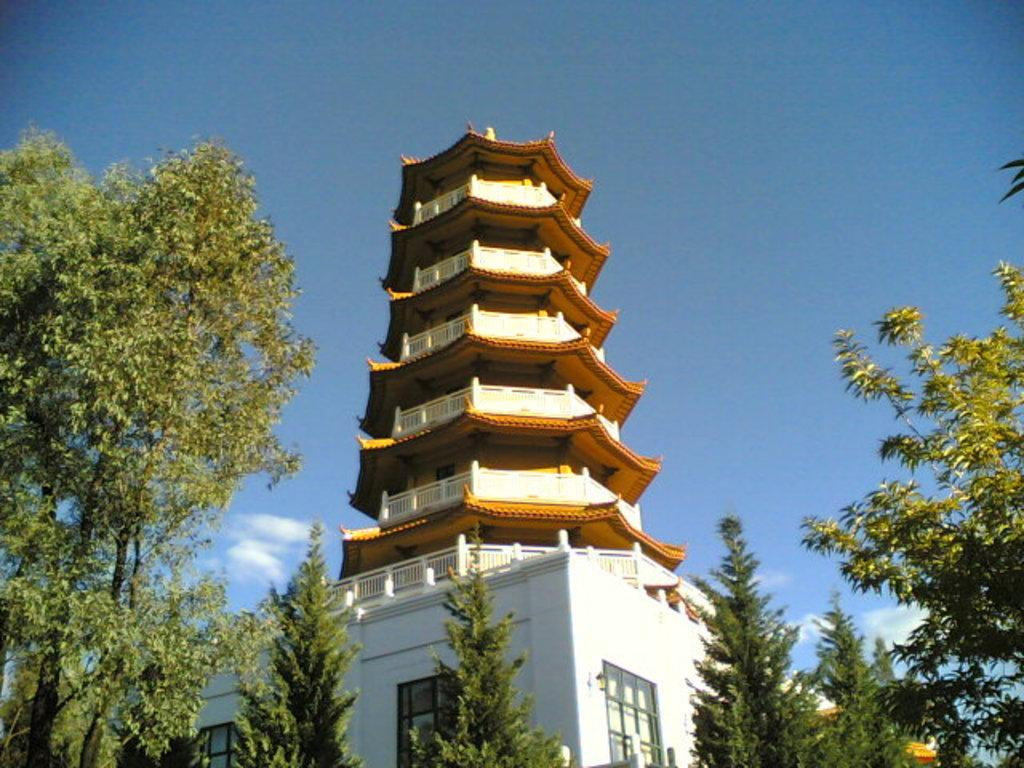What is the main structure in the picture? There is a Pagoda in the picture. What can be seen in front of the Pagoda? There are trees in front of the Pagoda. What is the color of the sky in the picture? The sky is blue in color. How many sheep can be seen grazing near the Pagoda in the picture? There are no sheep present in the picture; it only features a Pagoda and trees. What type of hair is visible on the Pagoda in the picture? The Pagoda is a structure made of materials like stone or wood, and it does not have hair. 